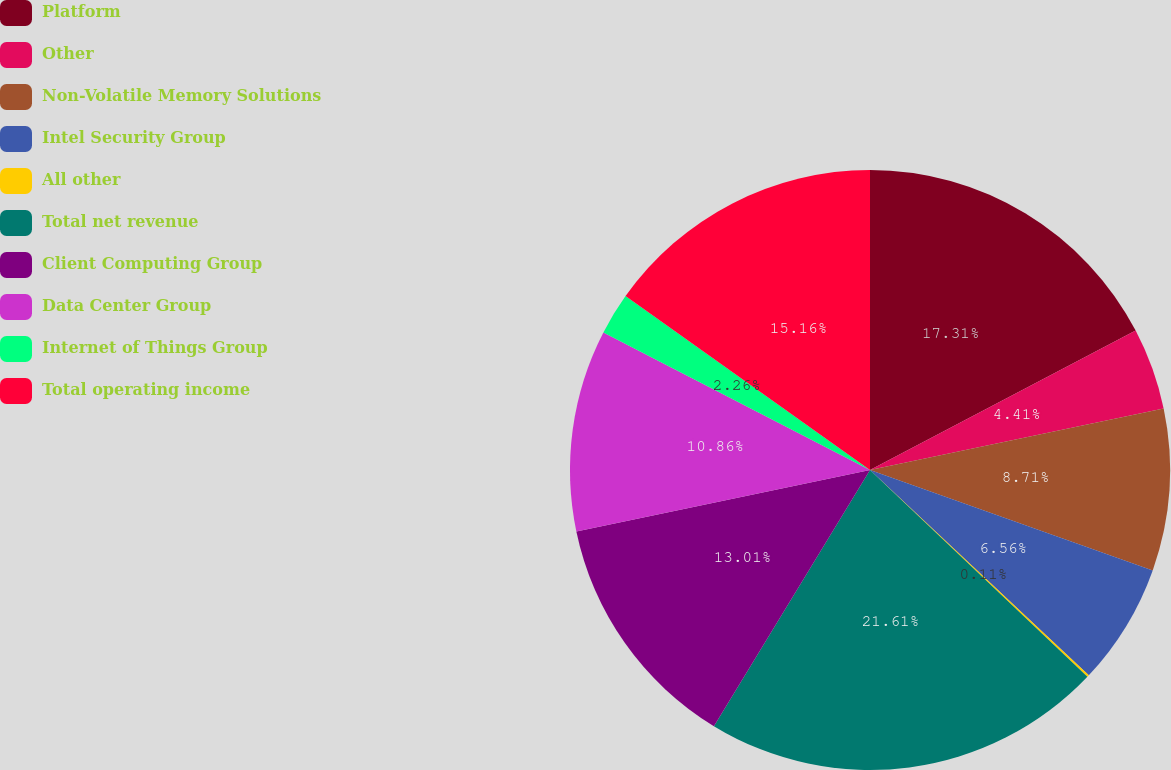Convert chart. <chart><loc_0><loc_0><loc_500><loc_500><pie_chart><fcel>Platform<fcel>Other<fcel>Non-Volatile Memory Solutions<fcel>Intel Security Group<fcel>All other<fcel>Total net revenue<fcel>Client Computing Group<fcel>Data Center Group<fcel>Internet of Things Group<fcel>Total operating income<nl><fcel>17.31%<fcel>4.41%<fcel>8.71%<fcel>6.56%<fcel>0.11%<fcel>21.61%<fcel>13.01%<fcel>10.86%<fcel>2.26%<fcel>15.16%<nl></chart> 